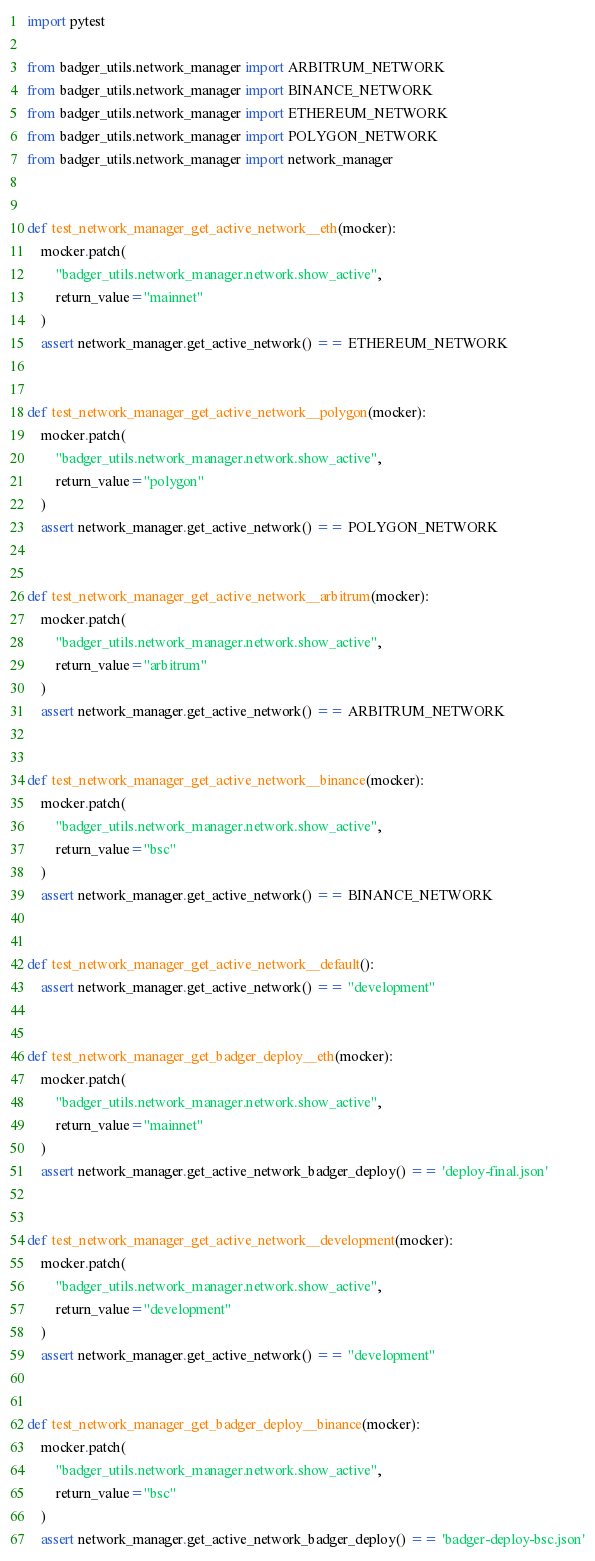<code> <loc_0><loc_0><loc_500><loc_500><_Python_>import pytest

from badger_utils.network_manager import ARBITRUM_NETWORK
from badger_utils.network_manager import BINANCE_NETWORK
from badger_utils.network_manager import ETHEREUM_NETWORK
from badger_utils.network_manager import POLYGON_NETWORK
from badger_utils.network_manager import network_manager


def test_network_manager_get_active_network__eth(mocker):
    mocker.patch(
        "badger_utils.network_manager.network.show_active",
        return_value="mainnet"
    )
    assert network_manager.get_active_network() == ETHEREUM_NETWORK


def test_network_manager_get_active_network__polygon(mocker):
    mocker.patch(
        "badger_utils.network_manager.network.show_active",
        return_value="polygon"
    )
    assert network_manager.get_active_network() == POLYGON_NETWORK


def test_network_manager_get_active_network__arbitrum(mocker):
    mocker.patch(
        "badger_utils.network_manager.network.show_active",
        return_value="arbitrum"
    )
    assert network_manager.get_active_network() == ARBITRUM_NETWORK


def test_network_manager_get_active_network__binance(mocker):
    mocker.patch(
        "badger_utils.network_manager.network.show_active",
        return_value="bsc"
    )
    assert network_manager.get_active_network() == BINANCE_NETWORK


def test_network_manager_get_active_network__default():
    assert network_manager.get_active_network() == "development"


def test_network_manager_get_badger_deploy__eth(mocker):
    mocker.patch(
        "badger_utils.network_manager.network.show_active",
        return_value="mainnet"
    )
    assert network_manager.get_active_network_badger_deploy() == 'deploy-final.json'


def test_network_manager_get_active_network__development(mocker):
    mocker.patch(
        "badger_utils.network_manager.network.show_active",
        return_value="development"
    )
    assert network_manager.get_active_network() == "development"


def test_network_manager_get_badger_deploy__binance(mocker):
    mocker.patch(
        "badger_utils.network_manager.network.show_active",
        return_value="bsc"
    )
    assert network_manager.get_active_network_badger_deploy() == 'badger-deploy-bsc.json'
</code> 